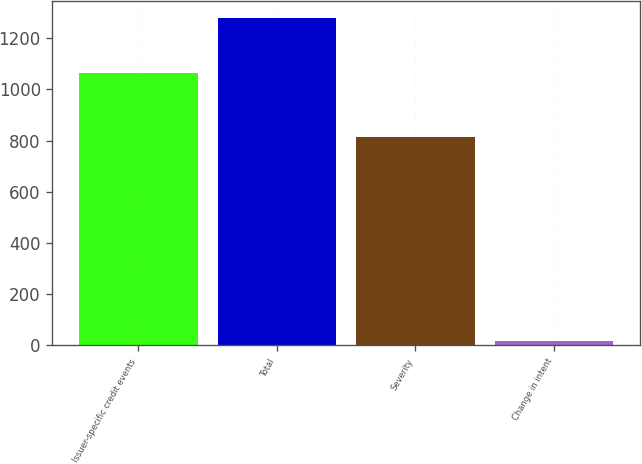<chart> <loc_0><loc_0><loc_500><loc_500><bar_chart><fcel>Issuer-specific credit events<fcel>Total<fcel>Severity<fcel>Change in intent<nl><fcel>1066<fcel>1281<fcel>816<fcel>19<nl></chart> 